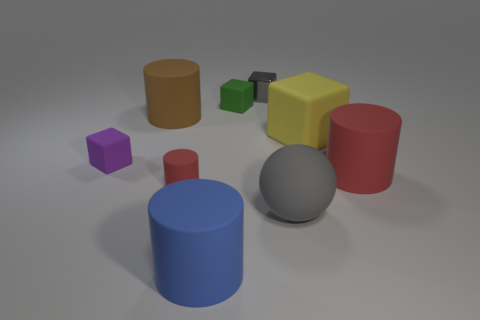The large matte object that is the same color as the shiny cube is what shape?
Your answer should be compact. Sphere. What number of brown cylinders are the same size as the gray sphere?
Make the answer very short. 1. Are there any large matte balls in front of the red cylinder on the right side of the big matte sphere?
Offer a terse response. Yes. How many objects are either spheres or yellow matte spheres?
Give a very brief answer. 1. There is a tiny matte block behind the purple block that is in front of the brown thing behind the gray rubber thing; what color is it?
Offer a terse response. Green. Are there any other things that have the same color as the metal object?
Provide a succinct answer. Yes. Do the green object and the shiny thing have the same size?
Provide a succinct answer. Yes. What number of objects are either tiny things that are in front of the big red object or small rubber things behind the large red matte cylinder?
Make the answer very short. 3. What material is the gray object that is behind the yellow object that is behind the large blue matte cylinder made of?
Keep it short and to the point. Metal. How many other things are there of the same material as the big brown object?
Give a very brief answer. 7. 